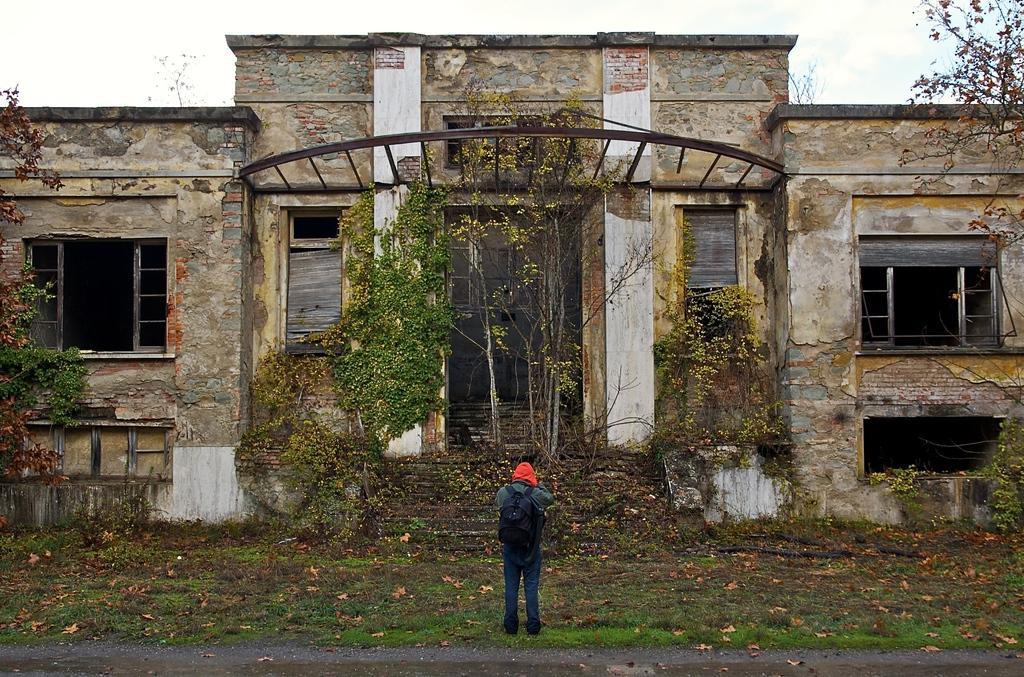In one or two sentences, can you explain what this image depicts? In this picture we can see a person carrying a bag, standing on the grass, road, dried leaves, trees, building with windows and in the background we can see the sky. 